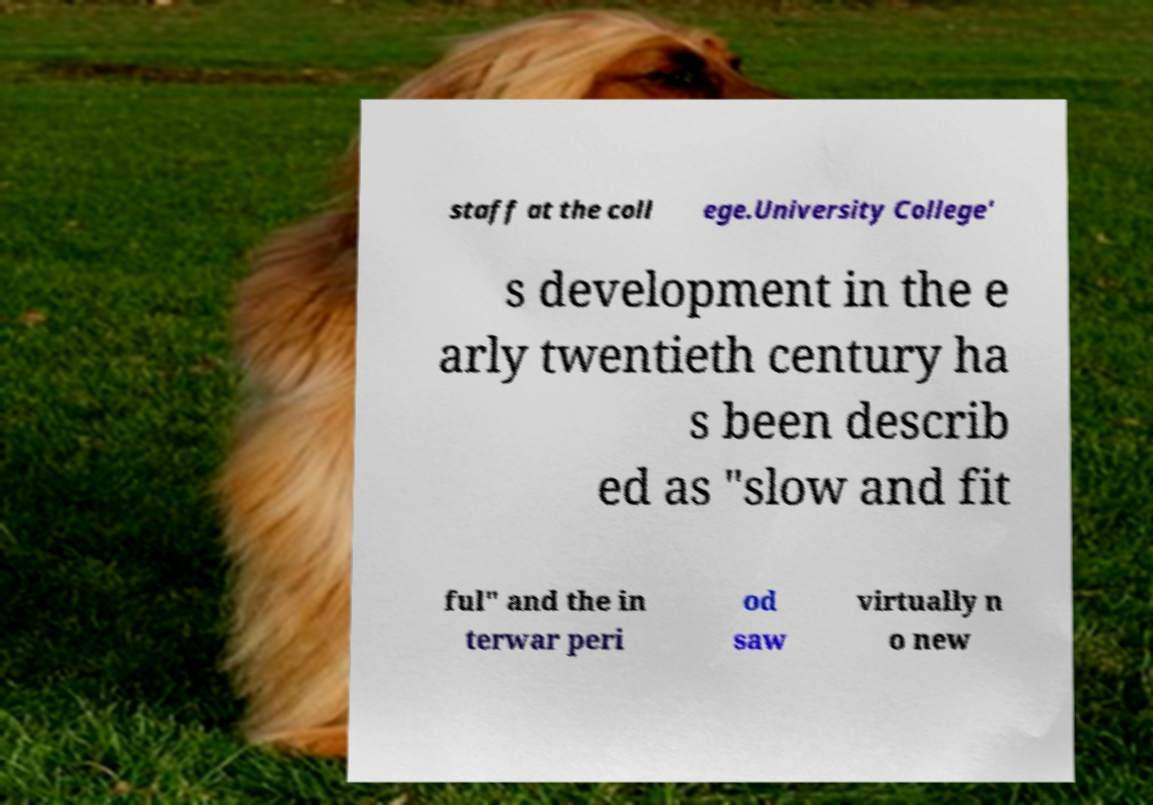There's text embedded in this image that I need extracted. Can you transcribe it verbatim? staff at the coll ege.University College' s development in the e arly twentieth century ha s been describ ed as "slow and fit ful" and the in terwar peri od saw virtually n o new 